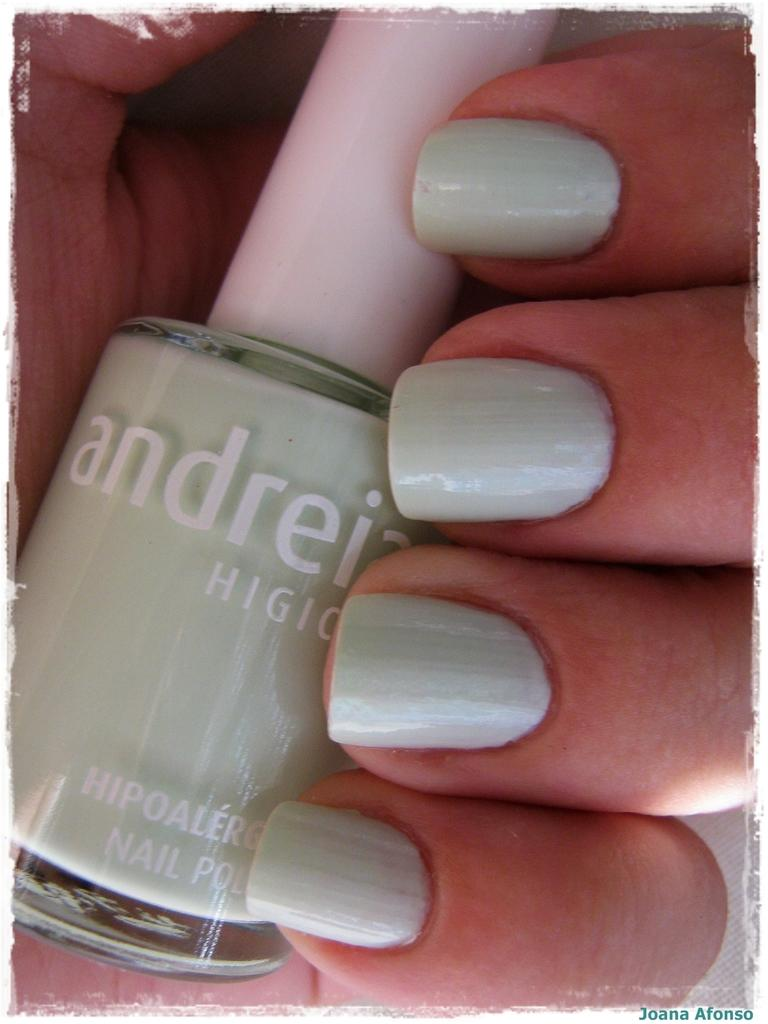<image>
Summarize the visual content of the image. Person with green nails holding a bottle of Andreia nail polish. 